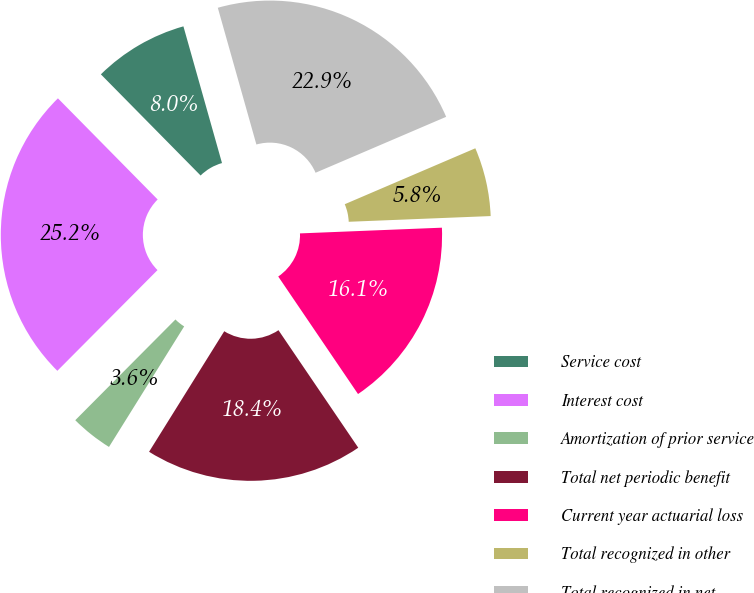<chart> <loc_0><loc_0><loc_500><loc_500><pie_chart><fcel>Service cost<fcel>Interest cost<fcel>Amortization of prior service<fcel>Total net periodic benefit<fcel>Current year actuarial loss<fcel>Total recognized in other<fcel>Total recognized in net<nl><fcel>8.01%<fcel>25.16%<fcel>3.58%<fcel>18.37%<fcel>16.15%<fcel>5.8%<fcel>22.94%<nl></chart> 